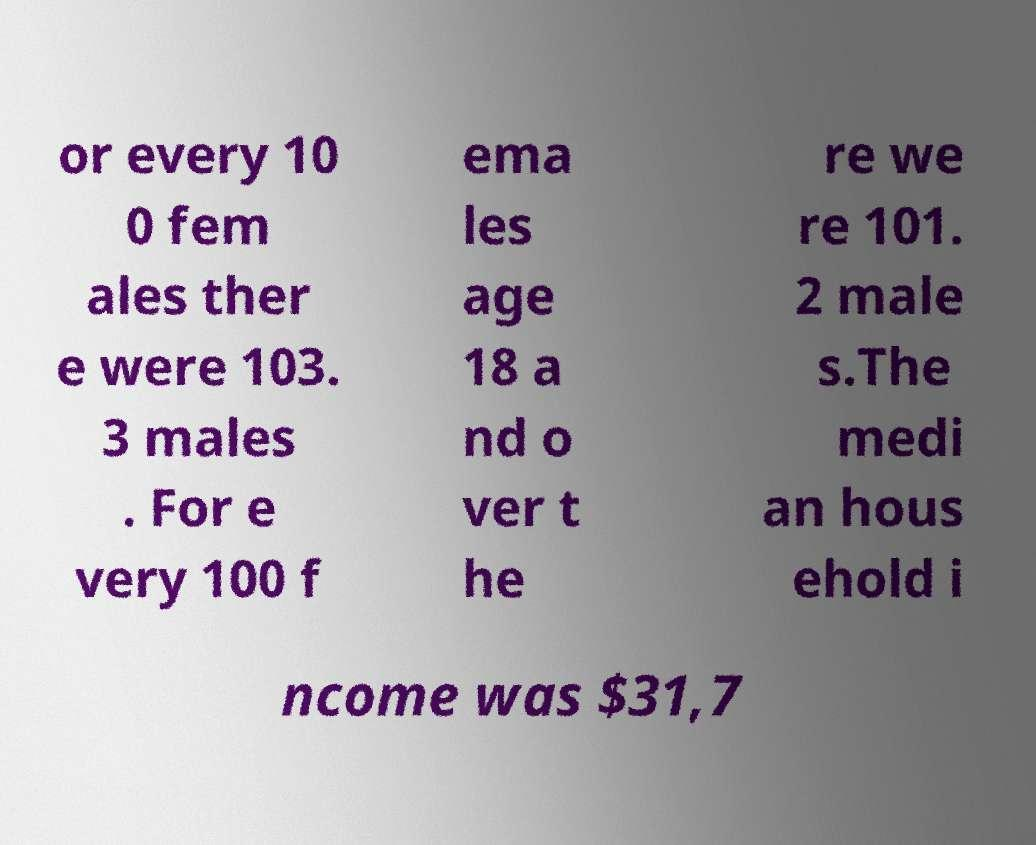I need the written content from this picture converted into text. Can you do that? or every 10 0 fem ales ther e were 103. 3 males . For e very 100 f ema les age 18 a nd o ver t he re we re 101. 2 male s.The medi an hous ehold i ncome was $31,7 